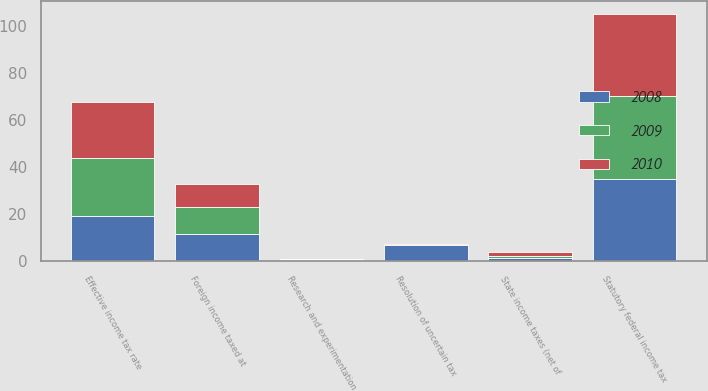Convert chart to OTSL. <chart><loc_0><loc_0><loc_500><loc_500><stacked_bar_chart><ecel><fcel>Statutory federal income tax<fcel>State income taxes (net of<fcel>Foreign income taxed at<fcel>Resolution of uncertain tax<fcel>Research and experimentation<fcel>Effective income tax rate<nl><fcel>2010<fcel>35<fcel>1.4<fcel>10<fcel>0.5<fcel>0.4<fcel>23.5<nl><fcel>2008<fcel>35<fcel>1.6<fcel>11.8<fcel>6.8<fcel>0.7<fcel>19.2<nl><fcel>2009<fcel>35<fcel>0.8<fcel>11.1<fcel>0.1<fcel>0.1<fcel>24.7<nl></chart> 